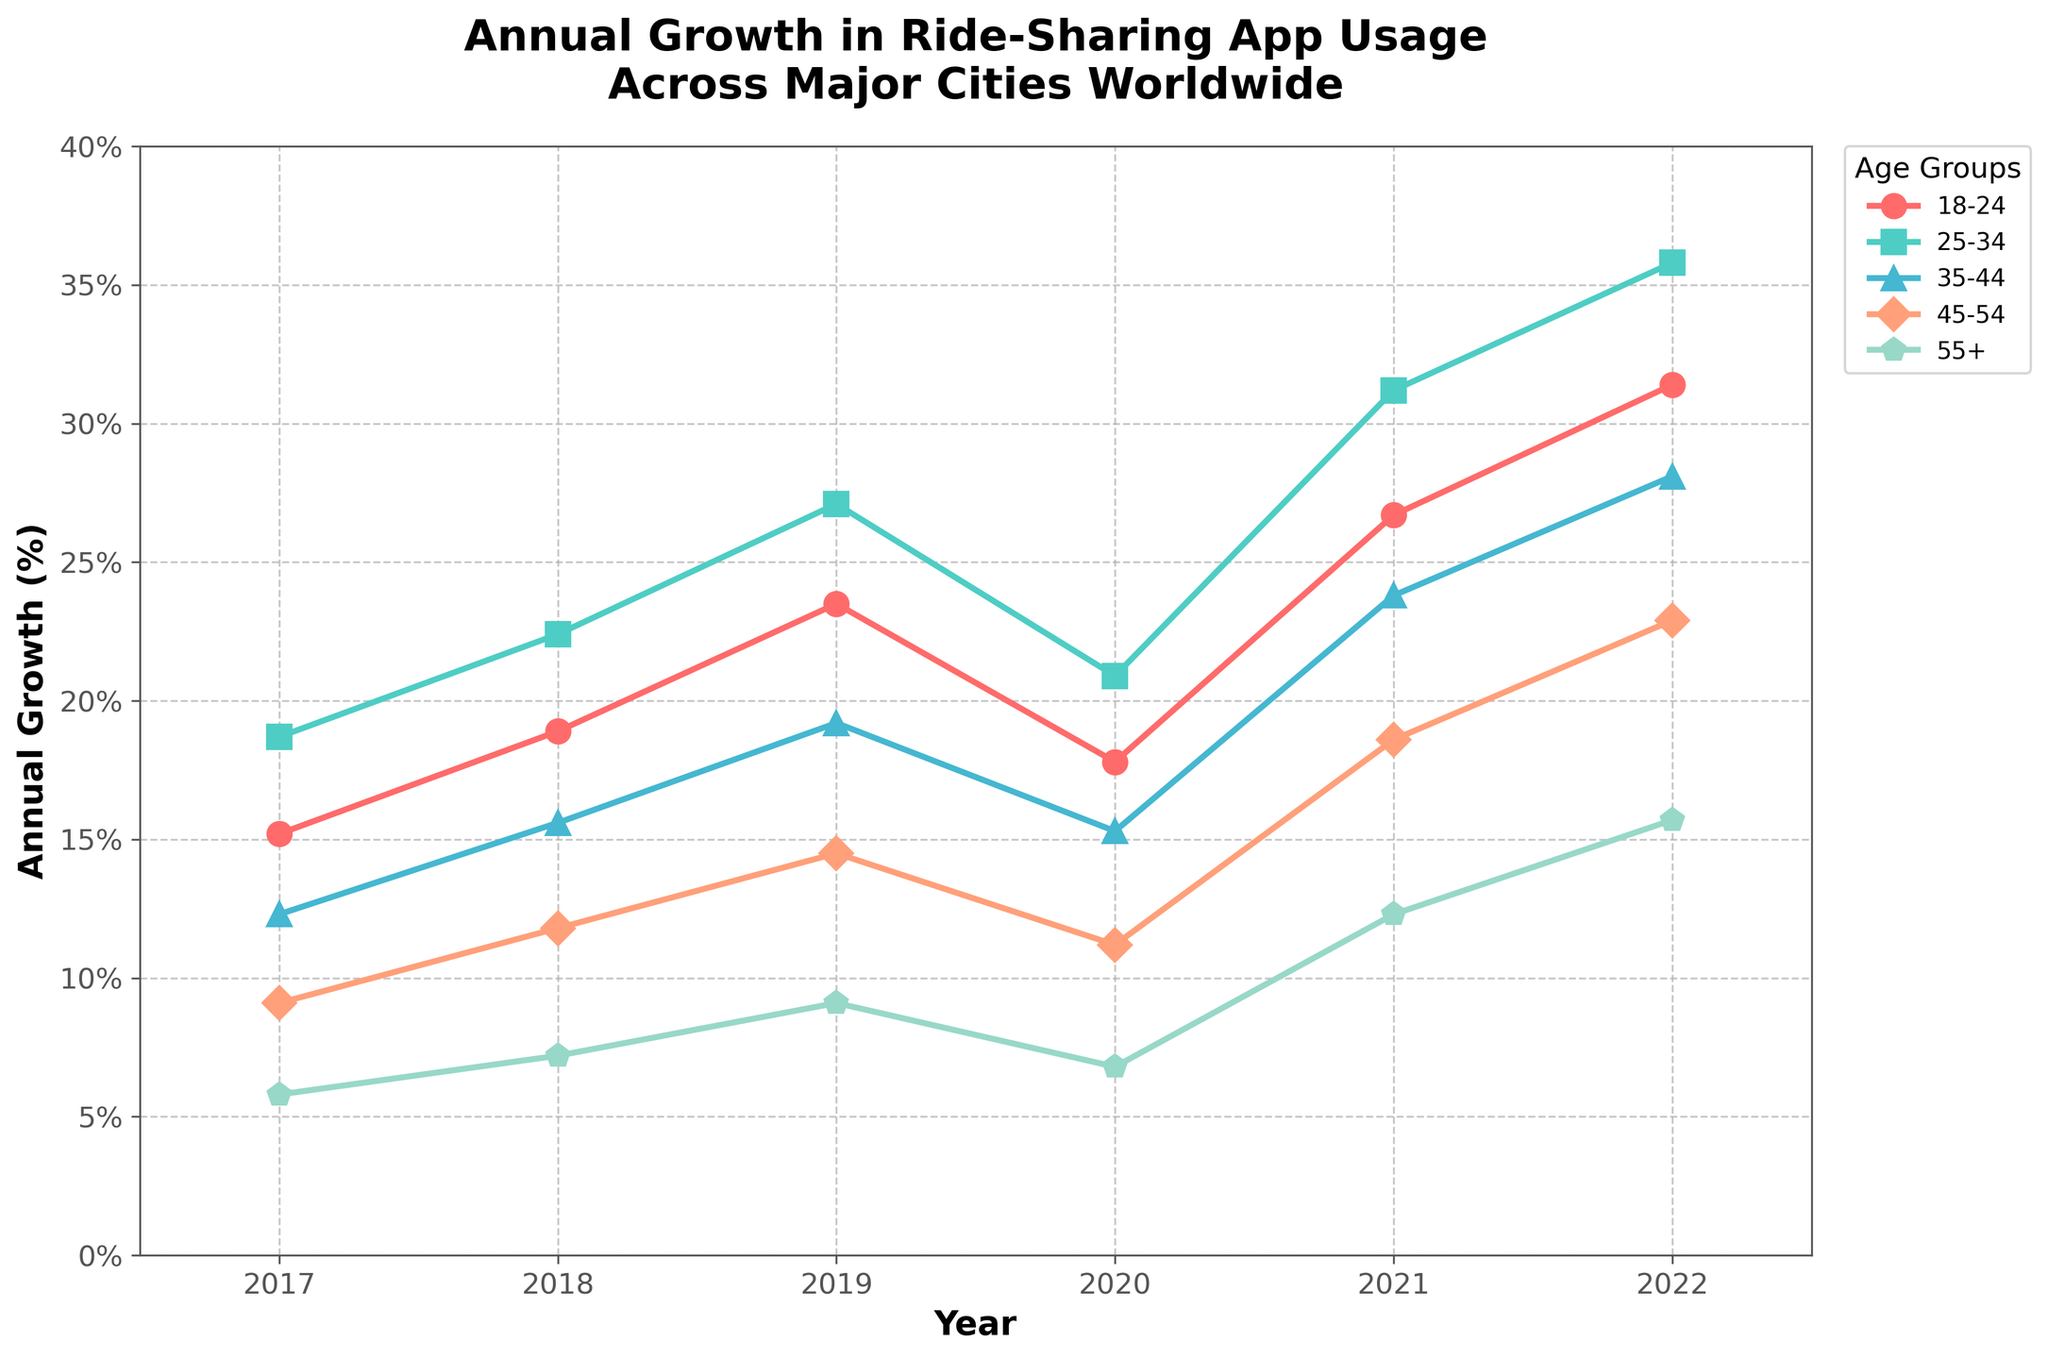What's the annual growth percentage for the 18-24 age group in 2022? Locate the line representing the 18-24 age group, which is marked with red color, and find its value at the year 2022.
Answer: 31.4% Which age group had the highest annual growth percentage in 2021? Compare the heights of the lines at the year 2021, specifically looking for the one that reaches the highest point. The line with the peak is the one for the 25-34 age group, in orange.
Answer: 25-34 age group What's the difference in growth percentage between the 35-44 and the 55+ age groups in 2019? Find the values for both age groups in 2019: 35-44 age group is 19.2% and 55+ age group is 9.1%. Subtract the latter from the former: 19.2% - 9.1%.
Answer: 10.1% On average, what was the annual growth percentage for the 45-54 age group from 2017 to 2022? Sum the annual growth percentages for the 45-54 age group from 2017 to 2022: 9.1% + 11.8% + 14.5% + 11.2% + 18.6% + 22.9% = 88.1%. Divide by the number of years: 88.1% / 6.
Answer: 14.7% Which year shows the lowest growth percentage for the 18-24 age group? Track the line representing the 18-24 age group across the years and identify the year where its value is the lowest, which is 2017 with a value of 15.2%.
Answer: 2017 Compare the growth trends of the 35-44 age group and the 55+ age group. Which group shows a steeper increase overall from 2017 to 2022? Analyze the slopes of both lines from 2017 to 2022. The 35-44 age group's growth rises from 12.3% to 28.1% (15.8% increase) and the 55+ age group rises from 5.8% to 15.7% (9.9% increase).
Answer: 35-44 age group Which age group's growth percentage crossed the 20% mark first, and in what year did this happen? Look at the years and identify the points where each age group's line crosses 20%. The 25-34 age group (green) crosses it first in 2018.
Answer: 25-34 age group in 2018 